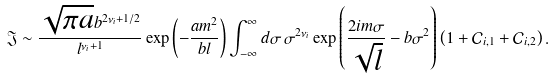<formula> <loc_0><loc_0><loc_500><loc_500>\mathfrak { J } \sim \frac { \sqrt { \pi a } b ^ { 2 \nu _ { i } + 1 / 2 } } { l ^ { \nu _ { i } + 1 } } \exp \left ( - \frac { a m ^ { 2 } } { b l } \right ) \int _ { - \infty } ^ { \infty } d \sigma \, \sigma ^ { 2 \nu _ { i } } \exp \left ( \frac { 2 i m \sigma } { \sqrt { l } } - b \sigma ^ { 2 } \right ) \left ( 1 + \mathcal { C } _ { i , 1 } + \mathcal { C } _ { i , 2 } \right ) .</formula> 